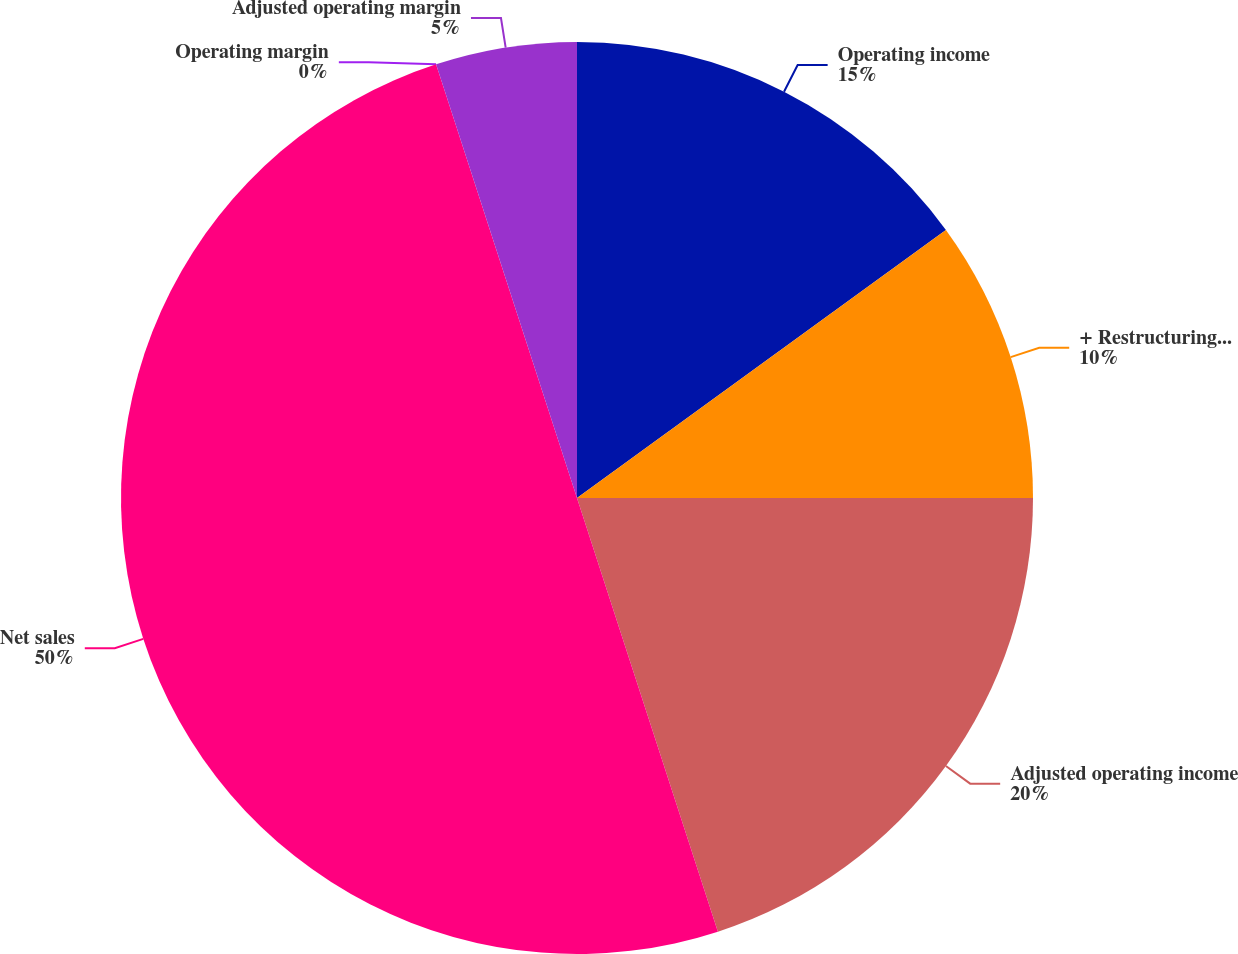Convert chart. <chart><loc_0><loc_0><loc_500><loc_500><pie_chart><fcel>Operating income<fcel>+ Restructuring expenses<fcel>Adjusted operating income<fcel>Net sales<fcel>Operating margin<fcel>Adjusted operating margin<nl><fcel>15.0%<fcel>10.0%<fcel>20.0%<fcel>50.0%<fcel>0.0%<fcel>5.0%<nl></chart> 